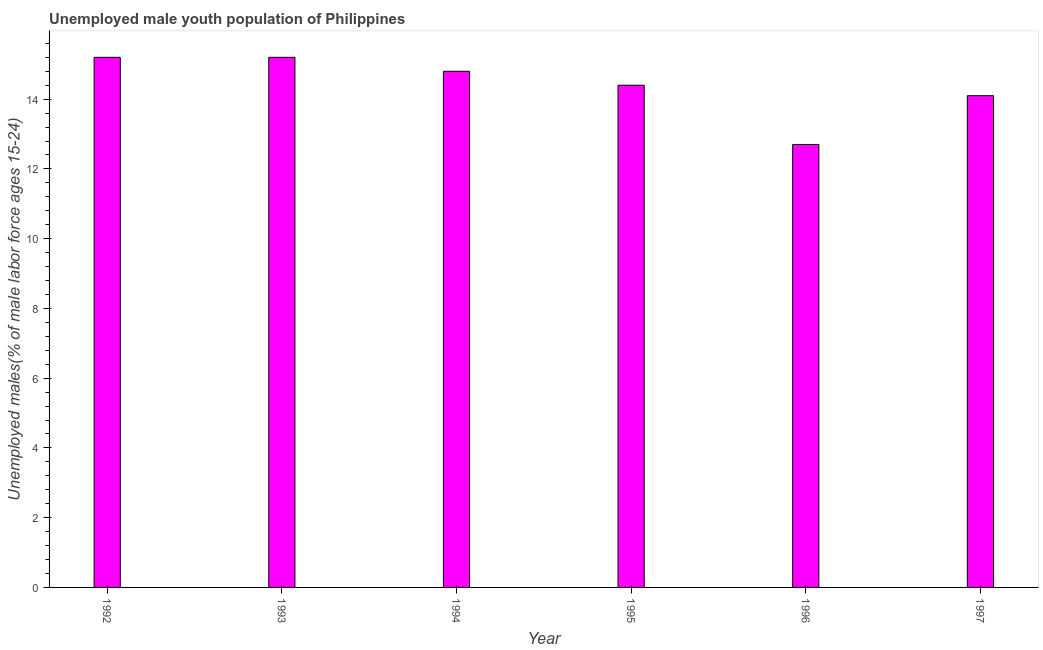What is the title of the graph?
Provide a succinct answer. Unemployed male youth population of Philippines. What is the label or title of the X-axis?
Provide a short and direct response. Year. What is the label or title of the Y-axis?
Keep it short and to the point. Unemployed males(% of male labor force ages 15-24). What is the unemployed male youth in 1992?
Offer a very short reply. 15.2. Across all years, what is the maximum unemployed male youth?
Keep it short and to the point. 15.2. Across all years, what is the minimum unemployed male youth?
Offer a terse response. 12.7. What is the sum of the unemployed male youth?
Make the answer very short. 86.4. What is the median unemployed male youth?
Provide a short and direct response. 14.6. What is the ratio of the unemployed male youth in 1994 to that in 1996?
Ensure brevity in your answer.  1.17. Is the unemployed male youth in 1993 less than that in 1994?
Give a very brief answer. No. Is the sum of the unemployed male youth in 1995 and 1996 greater than the maximum unemployed male youth across all years?
Your answer should be very brief. Yes. In how many years, is the unemployed male youth greater than the average unemployed male youth taken over all years?
Your answer should be very brief. 3. How many bars are there?
Ensure brevity in your answer.  6. Are all the bars in the graph horizontal?
Offer a terse response. No. How many years are there in the graph?
Keep it short and to the point. 6. What is the difference between two consecutive major ticks on the Y-axis?
Give a very brief answer. 2. Are the values on the major ticks of Y-axis written in scientific E-notation?
Offer a very short reply. No. What is the Unemployed males(% of male labor force ages 15-24) of 1992?
Give a very brief answer. 15.2. What is the Unemployed males(% of male labor force ages 15-24) of 1993?
Provide a succinct answer. 15.2. What is the Unemployed males(% of male labor force ages 15-24) in 1994?
Your answer should be compact. 14.8. What is the Unemployed males(% of male labor force ages 15-24) in 1995?
Your response must be concise. 14.4. What is the Unemployed males(% of male labor force ages 15-24) in 1996?
Provide a succinct answer. 12.7. What is the Unemployed males(% of male labor force ages 15-24) of 1997?
Offer a terse response. 14.1. What is the difference between the Unemployed males(% of male labor force ages 15-24) in 1993 and 1997?
Provide a short and direct response. 1.1. What is the difference between the Unemployed males(% of male labor force ages 15-24) in 1994 and 1995?
Provide a short and direct response. 0.4. What is the difference between the Unemployed males(% of male labor force ages 15-24) in 1995 and 1997?
Ensure brevity in your answer.  0.3. What is the ratio of the Unemployed males(% of male labor force ages 15-24) in 1992 to that in 1995?
Offer a terse response. 1.06. What is the ratio of the Unemployed males(% of male labor force ages 15-24) in 1992 to that in 1996?
Your answer should be very brief. 1.2. What is the ratio of the Unemployed males(% of male labor force ages 15-24) in 1992 to that in 1997?
Your answer should be compact. 1.08. What is the ratio of the Unemployed males(% of male labor force ages 15-24) in 1993 to that in 1994?
Offer a terse response. 1.03. What is the ratio of the Unemployed males(% of male labor force ages 15-24) in 1993 to that in 1995?
Make the answer very short. 1.06. What is the ratio of the Unemployed males(% of male labor force ages 15-24) in 1993 to that in 1996?
Your answer should be very brief. 1.2. What is the ratio of the Unemployed males(% of male labor force ages 15-24) in 1993 to that in 1997?
Offer a very short reply. 1.08. What is the ratio of the Unemployed males(% of male labor force ages 15-24) in 1994 to that in 1995?
Offer a very short reply. 1.03. What is the ratio of the Unemployed males(% of male labor force ages 15-24) in 1994 to that in 1996?
Your response must be concise. 1.17. What is the ratio of the Unemployed males(% of male labor force ages 15-24) in 1995 to that in 1996?
Make the answer very short. 1.13. What is the ratio of the Unemployed males(% of male labor force ages 15-24) in 1995 to that in 1997?
Offer a very short reply. 1.02. What is the ratio of the Unemployed males(% of male labor force ages 15-24) in 1996 to that in 1997?
Your response must be concise. 0.9. 